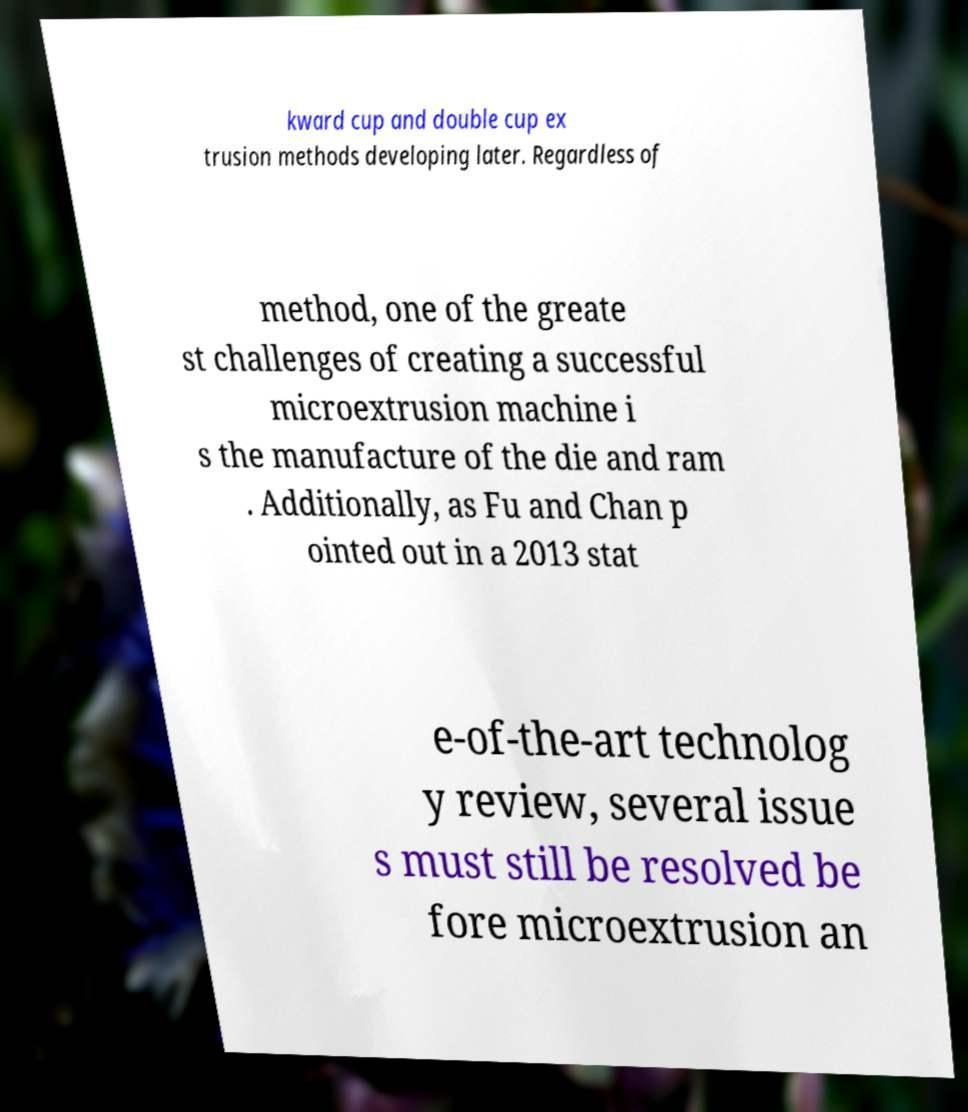I need the written content from this picture converted into text. Can you do that? kward cup and double cup ex trusion methods developing later. Regardless of method, one of the greate st challenges of creating a successful microextrusion machine i s the manufacture of the die and ram . Additionally, as Fu and Chan p ointed out in a 2013 stat e-of-the-art technolog y review, several issue s must still be resolved be fore microextrusion an 